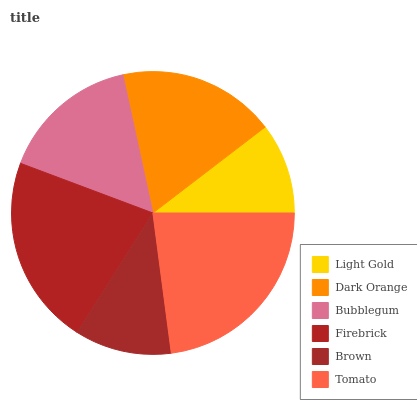Is Light Gold the minimum?
Answer yes or no. Yes. Is Tomato the maximum?
Answer yes or no. Yes. Is Dark Orange the minimum?
Answer yes or no. No. Is Dark Orange the maximum?
Answer yes or no. No. Is Dark Orange greater than Light Gold?
Answer yes or no. Yes. Is Light Gold less than Dark Orange?
Answer yes or no. Yes. Is Light Gold greater than Dark Orange?
Answer yes or no. No. Is Dark Orange less than Light Gold?
Answer yes or no. No. Is Dark Orange the high median?
Answer yes or no. Yes. Is Bubblegum the low median?
Answer yes or no. Yes. Is Firebrick the high median?
Answer yes or no. No. Is Light Gold the low median?
Answer yes or no. No. 